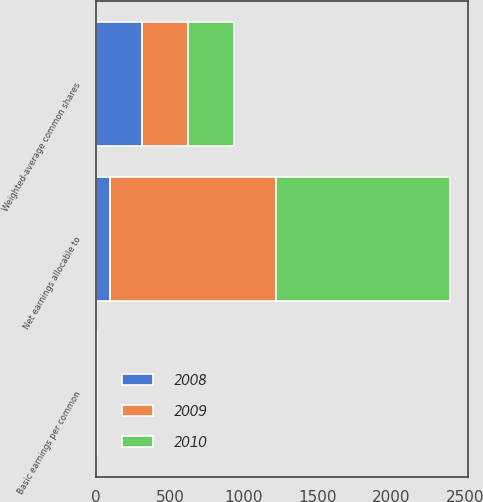<chart> <loc_0><loc_0><loc_500><loc_500><stacked_bar_chart><ecel><fcel>Net earnings allocable to<fcel>Weighted-average common shares<fcel>Basic earnings per common<nl><fcel>2010<fcel>1182<fcel>312<fcel>3.78<nl><fcel>2008<fcel>97<fcel>311<fcel>0.31<nl><fcel>2009<fcel>1123<fcel>309<fcel>3.64<nl></chart> 